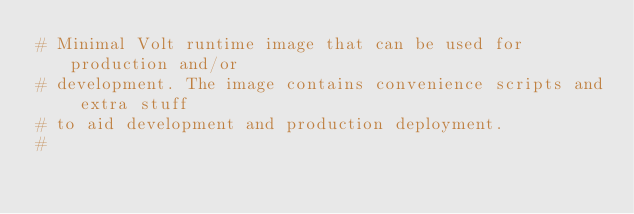<code> <loc_0><loc_0><loc_500><loc_500><_Dockerfile_># Minimal Volt runtime image that can be used for production and/or
# development. The image contains convenience scripts and extra stuff
# to aid development and production deployment.
#</code> 